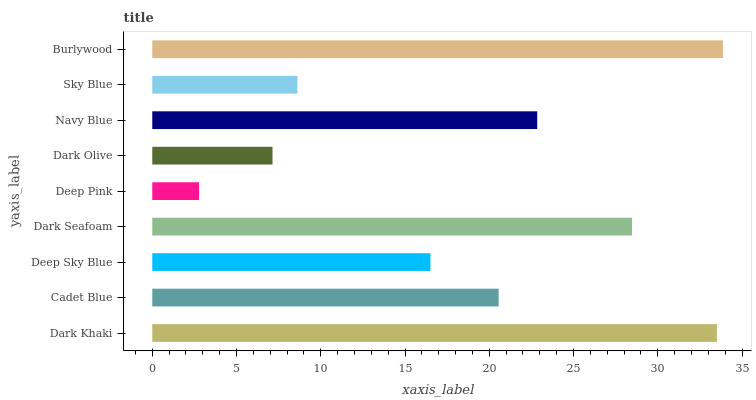Is Deep Pink the minimum?
Answer yes or no. Yes. Is Burlywood the maximum?
Answer yes or no. Yes. Is Cadet Blue the minimum?
Answer yes or no. No. Is Cadet Blue the maximum?
Answer yes or no. No. Is Dark Khaki greater than Cadet Blue?
Answer yes or no. Yes. Is Cadet Blue less than Dark Khaki?
Answer yes or no. Yes. Is Cadet Blue greater than Dark Khaki?
Answer yes or no. No. Is Dark Khaki less than Cadet Blue?
Answer yes or no. No. Is Cadet Blue the high median?
Answer yes or no. Yes. Is Cadet Blue the low median?
Answer yes or no. Yes. Is Dark Olive the high median?
Answer yes or no. No. Is Dark Khaki the low median?
Answer yes or no. No. 